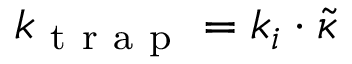<formula> <loc_0><loc_0><loc_500><loc_500>k _ { t r a p } = k _ { i } \cdot \tilde { \kappa }</formula> 